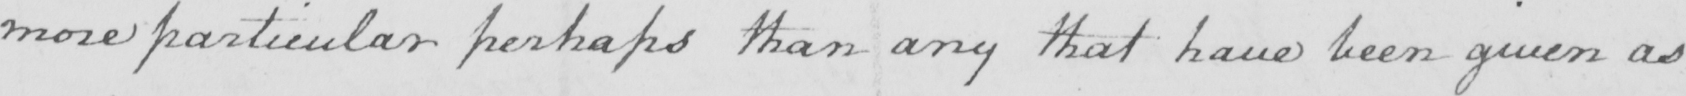Can you read and transcribe this handwriting? more particular perhaps than any that have been given as 